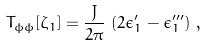<formula> <loc_0><loc_0><loc_500><loc_500>T _ { \phi \phi } [ \zeta _ { 1 } ] = \frac { J } { 2 \pi } \, \left ( 2 \epsilon _ { 1 } ^ { \prime } - \epsilon _ { 1 } ^ { \prime \prime \prime } \right ) \, ,</formula> 